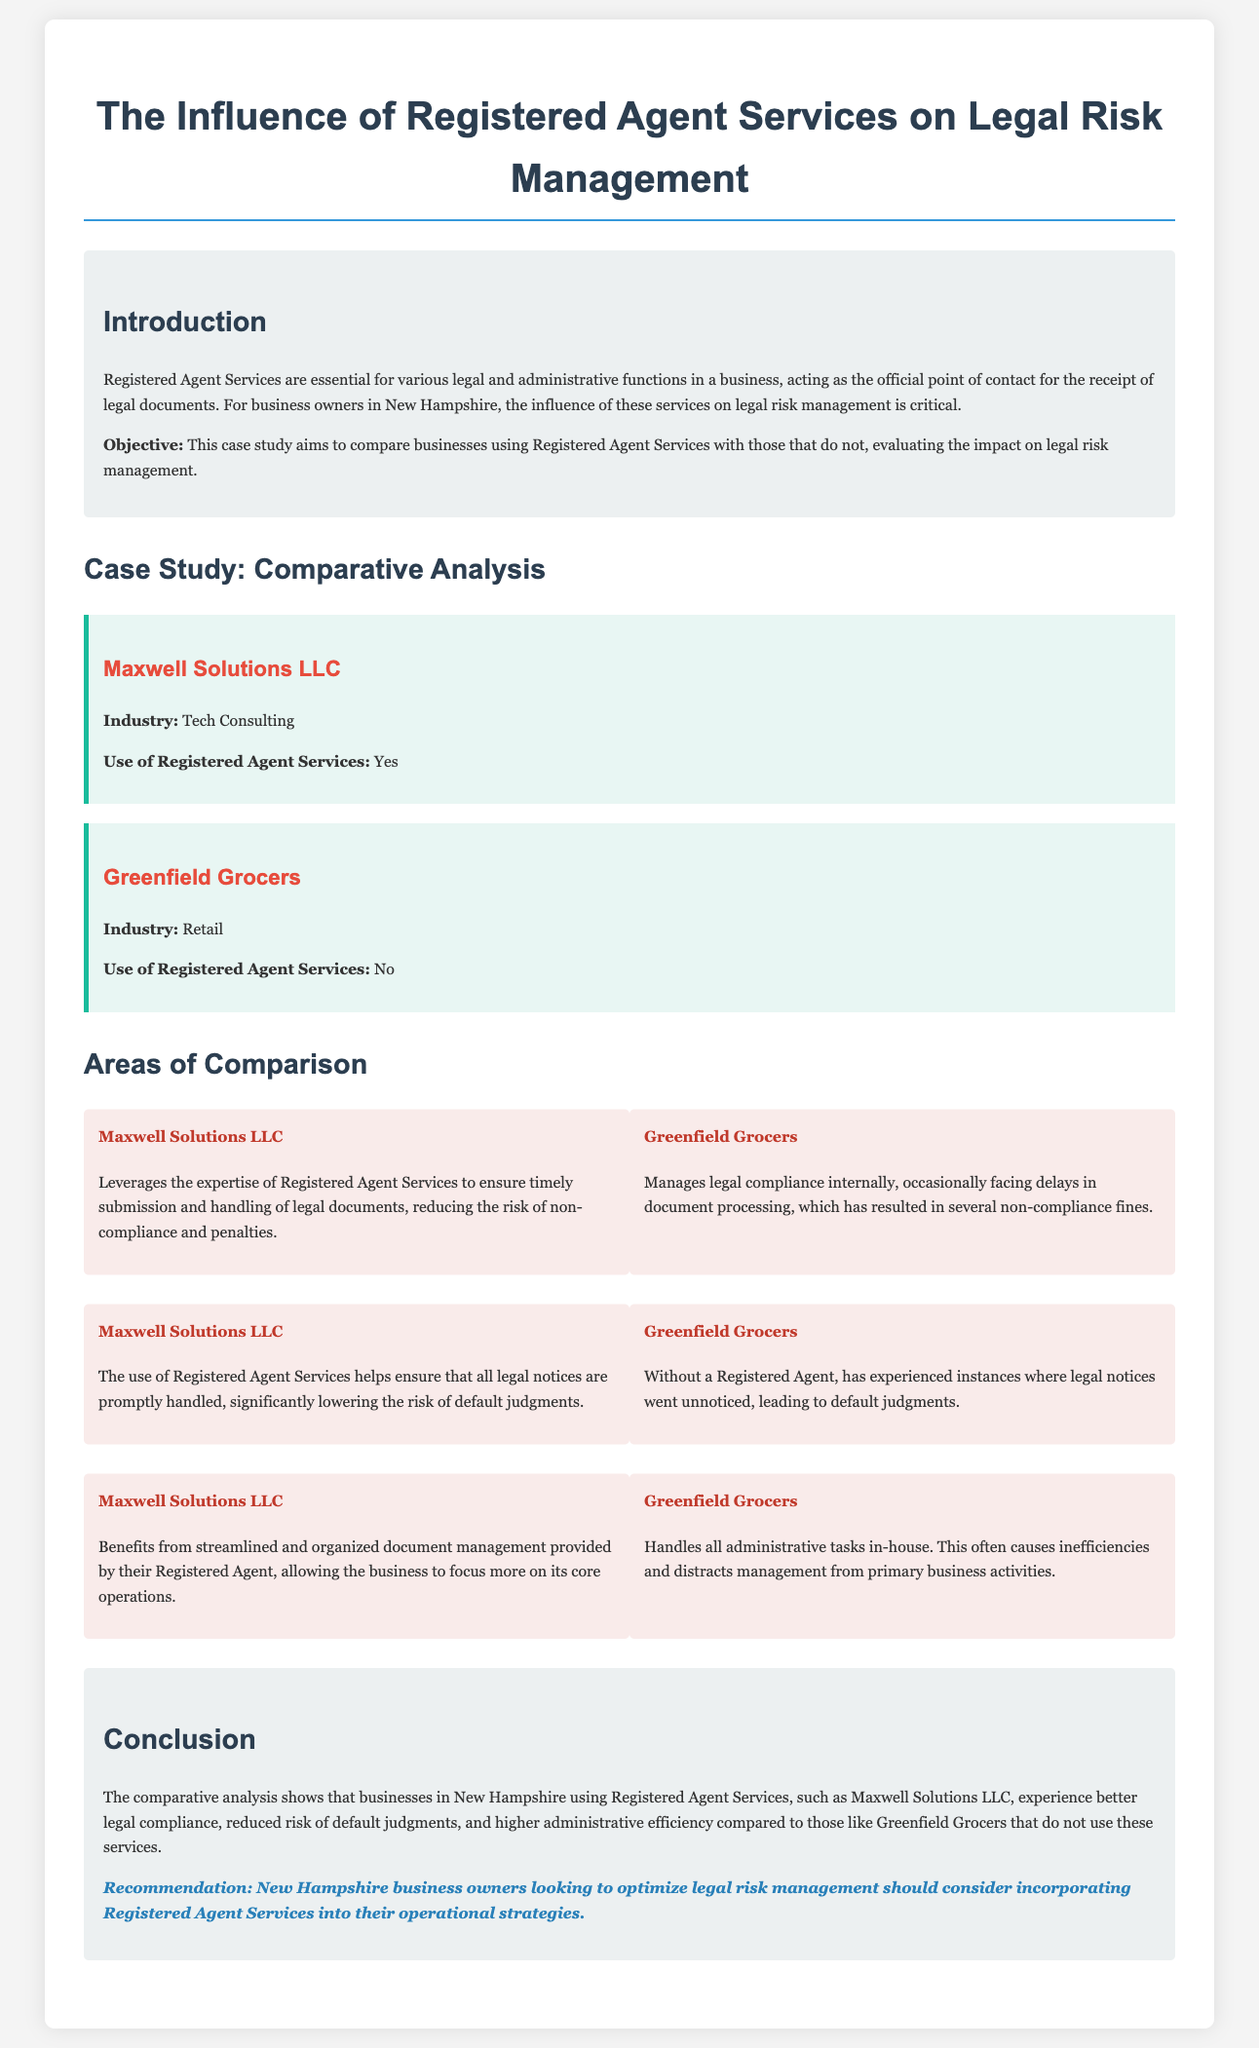What is the objective of the case study? The objective of the case study is outlined in the introduction, stating the aim to compare businesses using Registered Agent Services with those that do not.
Answer: Compare businesses using Registered Agent Services with those that do not What industry is Maxwell Solutions LLC in? This information is provided in the company section for Maxwell Solutions LLC.
Answer: Tech Consulting Does Greenfield Grocers use Registered Agent Services? The use of Registered Agent Services for Greenfield Grocers is explicitly mentioned in its company section.
Answer: No What is a significant risk faced by Greenfield Grocers? The comparison section states the occurrences that lead to non-compliance fines for Greenfield Grocers.
Answer: Non-compliance fines What administrative benefit does Maxwell Solutions LLC receive from using Registered Agent Services? The comparison item for Maxwell Solutions LLC highlights the benefits from their Registered Agent.
Answer: Streamlined and organized document management What is the recommendation for New Hampshire business owners? The conclusion section provides a clear recommendation for business owners regarding Registered Agent Services.
Answer: Incorporating Registered Agent Services into their operational strategies What effect does Maxwell Solutions LLC's use of Registered Agent Services have on legal notices? The document mentions how Registered Agent Services help with legal notices for Maxwell Solutions LLC.
Answer: Promptly handled How does the absence of Registered Agent Services influence Greenfield Grocers' management? The comparison for Greenfield Grocers describes how managing tasks in-house affects their operations.
Answer: Causes inefficiencies How does using Registered Agent Services affect legal compliance for businesses? The conclusion summarizes the impact of Registered Agent Services on legal compliance.
Answer: Better legal compliance 